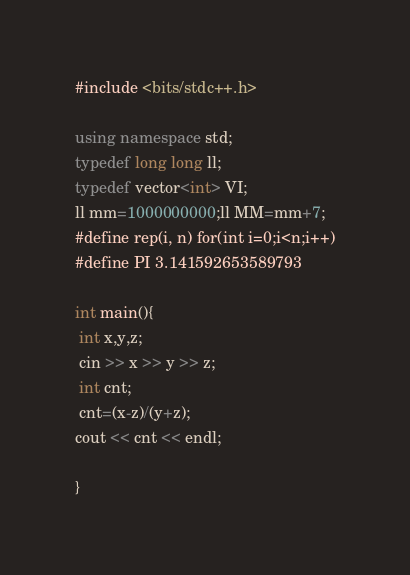Convert code to text. <code><loc_0><loc_0><loc_500><loc_500><_C++_>#include <bits/stdc++.h>
 
using namespace std;
typedef long long ll;
typedef vector<int> VI;
ll mm=1000000000;ll MM=mm+7;
#define rep(i, n) for(int i=0;i<n;i++)
#define PI 3.141592653589793

int main(){
 int x,y,z;
 cin >> x >> y >> z;
 int cnt;
 cnt=(x-z)/(y+z);
cout << cnt << endl;
 
}
</code> 